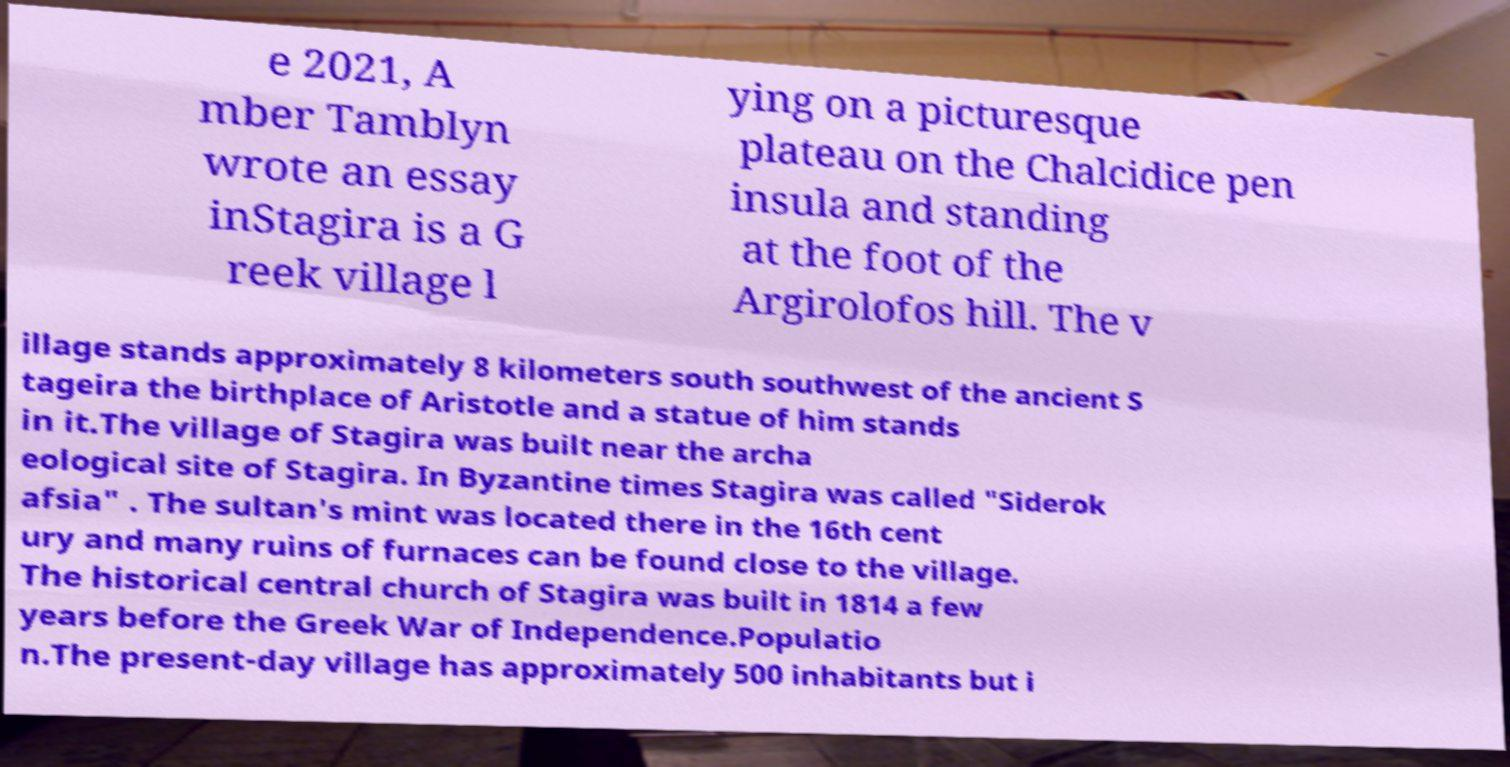There's text embedded in this image that I need extracted. Can you transcribe it verbatim? e 2021, A mber Tamblyn wrote an essay inStagira is a G reek village l ying on a picturesque plateau on the Chalcidice pen insula and standing at the foot of the Argirolofos hill. The v illage stands approximately 8 kilometers south southwest of the ancient S tageira the birthplace of Aristotle and a statue of him stands in it.The village of Stagira was built near the archa eological site of Stagira. In Byzantine times Stagira was called "Siderok afsia" . The sultan's mint was located there in the 16th cent ury and many ruins of furnaces can be found close to the village. The historical central church of Stagira was built in 1814 a few years before the Greek War of Independence.Populatio n.The present-day village has approximately 500 inhabitants but i 